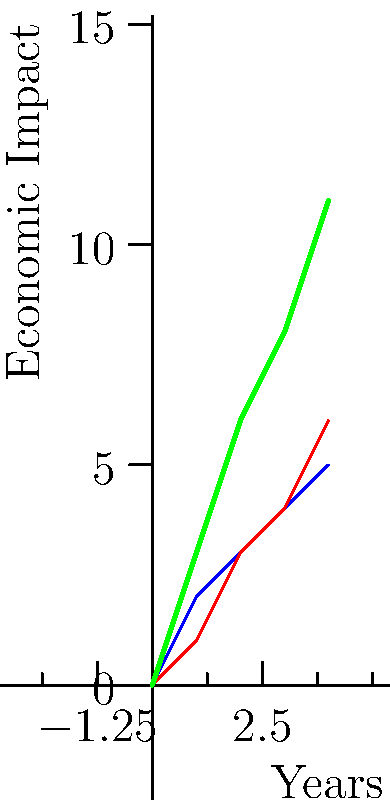Consider the graph showing the economic impact of two policies (A and B) over a 4-year period. If these policies are implemented simultaneously, what would be the cumulative economic impact after 3 years, assuming their effects are additive? Express your answer as a vector in the form $\langle x, y \rangle$, where $x$ represents the time in years and $y$ represents the total economic impact. To solve this problem, we need to follow these steps:

1) First, we identify the impact of each policy after 3 years:
   Policy A: 4 units
   Policy B: 4 units

2) Since the effects are additive, we sum these impacts:
   Total impact = 4 + 4 = 8 units

3) The time component is simply 3 years.

4) We can now express this as a vector:
   $\langle \text{time}, \text{impact} \rangle = \langle 3, 8 \rangle$

This vector representation allows us to model the cumulative effect of both policies over time, which is crucial in understanding the long-term implications of simultaneous economic policies.
Answer: $\langle 3, 8 \rangle$ 